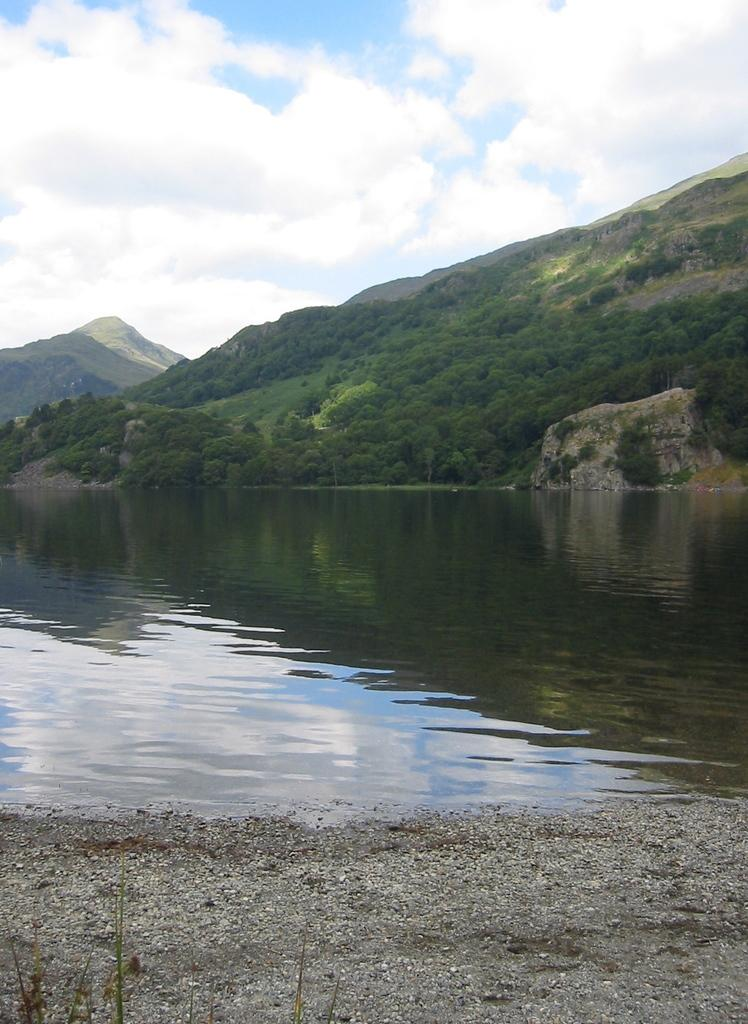What type of body of water is present in the image? There is a small water lake in the image. What can be seen in the background of the image? There is a huge mountain in the background of the image. What is the vegetation like on the mountain? The mountain has many trees. How would you describe the sky in the image? The sky is blue, and there are clouds in the sky. What decision is the beast making in the image? There is no beast present in the image, so no decision can be observed. How many trucks are visible in the image? There are no trucks present in the image. 